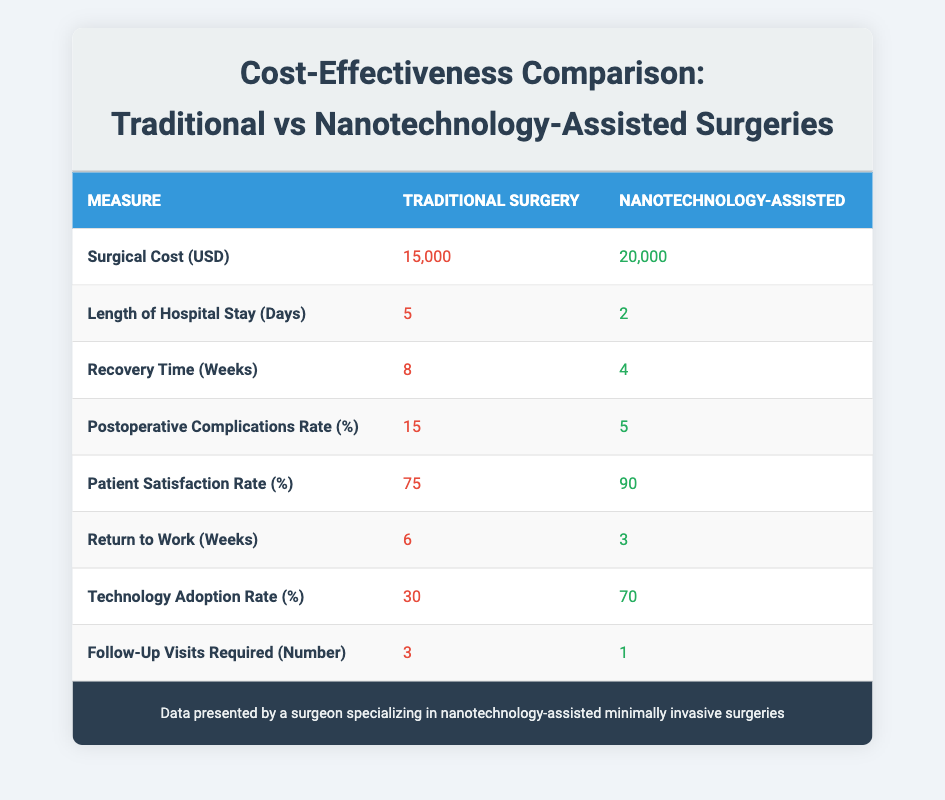What is the surgical cost for traditional surgery? From the table, the surgical cost for traditional surgery is listed under the corresponding measure, which states it is 15,000 USD.
Answer: 15,000 USD What is the length of hospital stay for nanotechnology-assisted surgeries? Referring to the table, the length of hospital stay for nanotechnology-assisted surgeries is clearly marked as 2 days.
Answer: 2 days How much shorter is the recovery time in nanotechnology-assisted surgeries compared to traditional surgeries? The recovery time for traditional surgeries is 8 weeks, and for nanotechnology-assisted surgeries, it is 4 weeks. To find the difference: 8 - 4 = 4 weeks shorter.
Answer: 4 weeks What is the postoperative complications rate for traditional surgery? The table indicates that the postoperative complications rate for traditional surgery is 15%.
Answer: 15% What is the average patient satisfaction rate between traditional and nanotechnology-assisted surgeries? To find the average, we add both satisfaction rates: 75 (traditional) + 90 (nanotechnology) = 165, then divide by 2: 165 / 2 = 82.5%.
Answer: 82.5% Is the technology adoption rate higher for nanotechnology-assisted surgeries than for traditional surgeries? The technology adoption rate for traditional surgery is 30% and for nanotechnology-assisted surgery is 70%. Since 70% is greater than 30%, the statement is true.
Answer: Yes How many fewer follow-up visits are required for nanotechnology-assisted surgeries compared to traditional surgeries? Traditional surgeries require 3 follow-up visits, while nanotechnology-assisted surgeries require only 1 visit. Therefore, 3 - 1 = 2 fewer visits are required.
Answer: 2 fewer visits What is the percentage difference in patient satisfaction rates between the two types of surgeries? The patient satisfaction rates are 75% for traditional and 90% for nanotechnology-assisted surgeries. The difference is 90 - 75 = 15%, and to find the percentage difference: (15 / 75) * 100 = 20%.
Answer: 20% How does the return to work time compare between traditional and nanotechnology-assisted surgeries? Traditional surgery allows a return to work in 6 weeks, while nanotechnology-assisted surgery allows it in 3 weeks. Therefore, patients return to work 3 weeks sooner with nanotechnology-assisted surgeries.
Answer: 3 weeks sooner Considering all measures, can we conclude that nanotechnology-assisted surgeries are more cost-effective? While the surgical cost is higher for nanotechnology-assisted surgeries at 20,000 USD compared to 15,000 USD for traditional surgeries, several other benefits are noted, such as shorter hospital stays, faster recovery, fewer complications, higher satisfaction, and fewer follow-up visits. These factors can suggest that they may achieve better outcomes, which could justify the higher cost, thus considered more cost-effective overall.
Answer: Yes, they are more cost-effective 